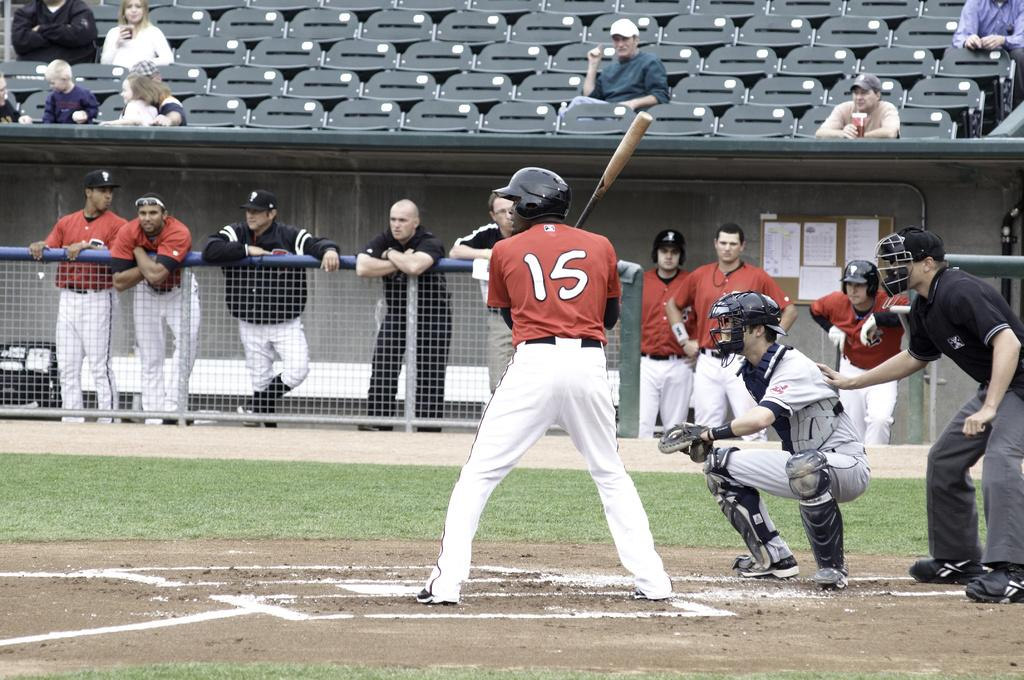<image>
Provide a brief description of the given image. A baseball player wearing number 15 stands at plate. 